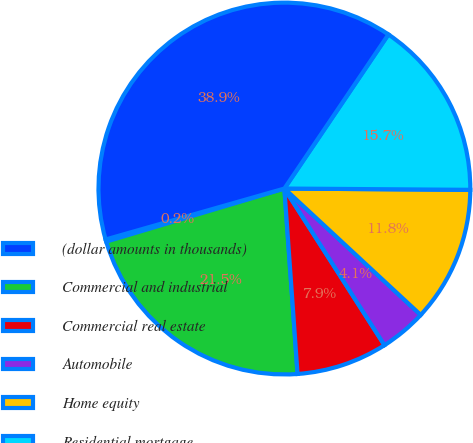Convert chart to OTSL. <chart><loc_0><loc_0><loc_500><loc_500><pie_chart><fcel>(dollar amounts in thousands)<fcel>Commercial and industrial<fcel>Commercial real estate<fcel>Automobile<fcel>Home equity<fcel>Residential mortgage<fcel>Total nonaccrual loans<nl><fcel>0.19%<fcel>21.52%<fcel>7.92%<fcel>4.05%<fcel>11.79%<fcel>15.66%<fcel>38.87%<nl></chart> 